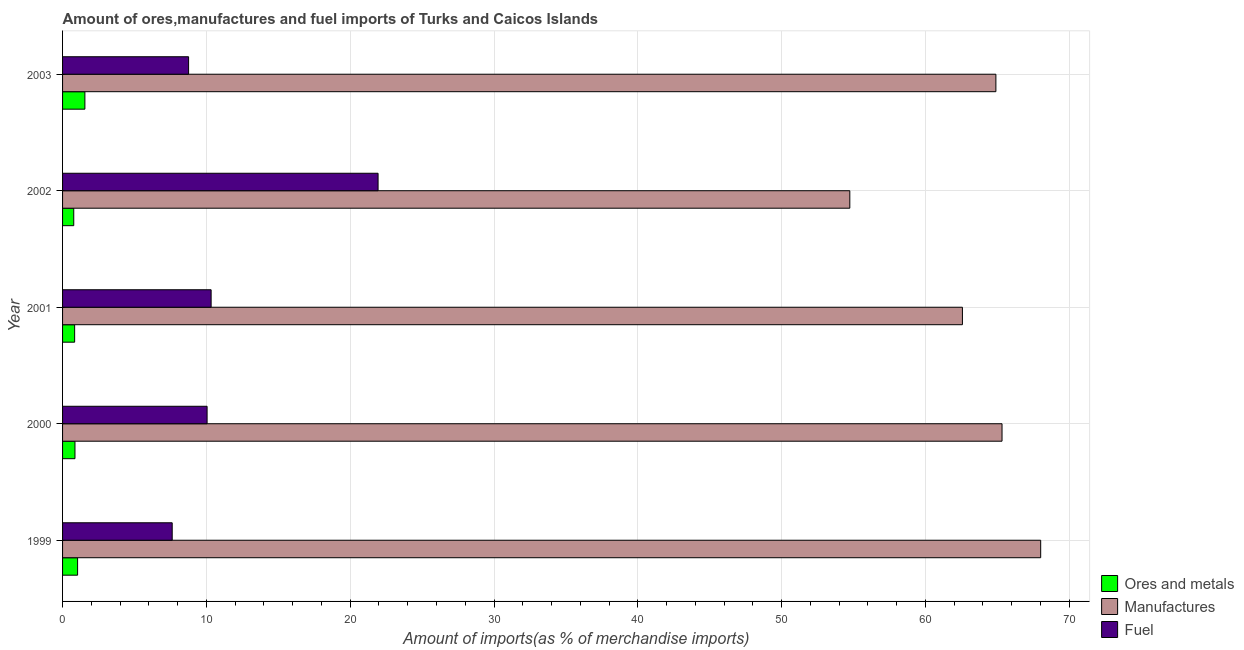How many different coloured bars are there?
Make the answer very short. 3. Are the number of bars per tick equal to the number of legend labels?
Your answer should be very brief. Yes. Are the number of bars on each tick of the Y-axis equal?
Your answer should be very brief. Yes. In how many cases, is the number of bars for a given year not equal to the number of legend labels?
Keep it short and to the point. 0. What is the percentage of manufactures imports in 2003?
Give a very brief answer. 64.9. Across all years, what is the maximum percentage of ores and metals imports?
Ensure brevity in your answer.  1.55. Across all years, what is the minimum percentage of fuel imports?
Keep it short and to the point. 7.62. In which year was the percentage of ores and metals imports maximum?
Ensure brevity in your answer.  2003. What is the total percentage of ores and metals imports in the graph?
Your response must be concise. 5.08. What is the difference between the percentage of fuel imports in 1999 and that in 2003?
Your answer should be very brief. -1.14. What is the difference between the percentage of ores and metals imports in 1999 and the percentage of fuel imports in 2003?
Your answer should be very brief. -7.72. What is the average percentage of fuel imports per year?
Give a very brief answer. 11.74. In the year 2000, what is the difference between the percentage of fuel imports and percentage of manufactures imports?
Your answer should be very brief. -55.28. In how many years, is the percentage of ores and metals imports greater than 4 %?
Make the answer very short. 0. What is the ratio of the percentage of ores and metals imports in 1999 to that in 2002?
Ensure brevity in your answer.  1.34. Is the difference between the percentage of fuel imports in 2001 and 2003 greater than the difference between the percentage of manufactures imports in 2001 and 2003?
Your response must be concise. Yes. What is the difference between the highest and the second highest percentage of ores and metals imports?
Provide a succinct answer. 0.51. What is the difference between the highest and the lowest percentage of fuel imports?
Provide a short and direct response. 14.31. In how many years, is the percentage of ores and metals imports greater than the average percentage of ores and metals imports taken over all years?
Keep it short and to the point. 2. Is the sum of the percentage of ores and metals imports in 2002 and 2003 greater than the maximum percentage of manufactures imports across all years?
Ensure brevity in your answer.  No. What does the 1st bar from the top in 2001 represents?
Provide a succinct answer. Fuel. What does the 2nd bar from the bottom in 2003 represents?
Keep it short and to the point. Manufactures. Is it the case that in every year, the sum of the percentage of ores and metals imports and percentage of manufactures imports is greater than the percentage of fuel imports?
Offer a terse response. Yes. How many bars are there?
Your answer should be compact. 15. How many years are there in the graph?
Give a very brief answer. 5. What is the difference between two consecutive major ticks on the X-axis?
Offer a very short reply. 10. Are the values on the major ticks of X-axis written in scientific E-notation?
Provide a short and direct response. No. Does the graph contain any zero values?
Keep it short and to the point. No. How many legend labels are there?
Make the answer very short. 3. How are the legend labels stacked?
Make the answer very short. Vertical. What is the title of the graph?
Ensure brevity in your answer.  Amount of ores,manufactures and fuel imports of Turks and Caicos Islands. Does "Services" appear as one of the legend labels in the graph?
Offer a very short reply. No. What is the label or title of the X-axis?
Your answer should be compact. Amount of imports(as % of merchandise imports). What is the Amount of imports(as % of merchandise imports) in Ores and metals in 1999?
Provide a succinct answer. 1.04. What is the Amount of imports(as % of merchandise imports) of Manufactures in 1999?
Make the answer very short. 68.01. What is the Amount of imports(as % of merchandise imports) in Fuel in 1999?
Ensure brevity in your answer.  7.62. What is the Amount of imports(as % of merchandise imports) of Ores and metals in 2000?
Offer a terse response. 0.86. What is the Amount of imports(as % of merchandise imports) in Manufactures in 2000?
Make the answer very short. 65.32. What is the Amount of imports(as % of merchandise imports) of Fuel in 2000?
Offer a terse response. 10.05. What is the Amount of imports(as % of merchandise imports) in Ores and metals in 2001?
Make the answer very short. 0.84. What is the Amount of imports(as % of merchandise imports) of Manufactures in 2001?
Offer a very short reply. 62.57. What is the Amount of imports(as % of merchandise imports) in Fuel in 2001?
Your answer should be very brief. 10.33. What is the Amount of imports(as % of merchandise imports) in Ores and metals in 2002?
Keep it short and to the point. 0.78. What is the Amount of imports(as % of merchandise imports) of Manufactures in 2002?
Your answer should be very brief. 54.74. What is the Amount of imports(as % of merchandise imports) in Fuel in 2002?
Offer a terse response. 21.94. What is the Amount of imports(as % of merchandise imports) in Ores and metals in 2003?
Your answer should be compact. 1.55. What is the Amount of imports(as % of merchandise imports) of Manufactures in 2003?
Provide a short and direct response. 64.9. What is the Amount of imports(as % of merchandise imports) of Fuel in 2003?
Ensure brevity in your answer.  8.76. Across all years, what is the maximum Amount of imports(as % of merchandise imports) of Ores and metals?
Make the answer very short. 1.55. Across all years, what is the maximum Amount of imports(as % of merchandise imports) of Manufactures?
Offer a terse response. 68.01. Across all years, what is the maximum Amount of imports(as % of merchandise imports) of Fuel?
Ensure brevity in your answer.  21.94. Across all years, what is the minimum Amount of imports(as % of merchandise imports) in Ores and metals?
Your answer should be compact. 0.78. Across all years, what is the minimum Amount of imports(as % of merchandise imports) in Manufactures?
Your answer should be very brief. 54.74. Across all years, what is the minimum Amount of imports(as % of merchandise imports) in Fuel?
Provide a short and direct response. 7.62. What is the total Amount of imports(as % of merchandise imports) of Ores and metals in the graph?
Give a very brief answer. 5.08. What is the total Amount of imports(as % of merchandise imports) in Manufactures in the graph?
Provide a short and direct response. 315.55. What is the total Amount of imports(as % of merchandise imports) in Fuel in the graph?
Give a very brief answer. 58.7. What is the difference between the Amount of imports(as % of merchandise imports) in Ores and metals in 1999 and that in 2000?
Give a very brief answer. 0.18. What is the difference between the Amount of imports(as % of merchandise imports) in Manufactures in 1999 and that in 2000?
Make the answer very short. 2.69. What is the difference between the Amount of imports(as % of merchandise imports) in Fuel in 1999 and that in 2000?
Your answer should be compact. -2.43. What is the difference between the Amount of imports(as % of merchandise imports) of Ores and metals in 1999 and that in 2001?
Provide a succinct answer. 0.2. What is the difference between the Amount of imports(as % of merchandise imports) in Manufactures in 1999 and that in 2001?
Ensure brevity in your answer.  5.44. What is the difference between the Amount of imports(as % of merchandise imports) in Fuel in 1999 and that in 2001?
Offer a very short reply. -2.71. What is the difference between the Amount of imports(as % of merchandise imports) of Ores and metals in 1999 and that in 2002?
Offer a terse response. 0.27. What is the difference between the Amount of imports(as % of merchandise imports) of Manufactures in 1999 and that in 2002?
Make the answer very short. 13.27. What is the difference between the Amount of imports(as % of merchandise imports) in Fuel in 1999 and that in 2002?
Your answer should be compact. -14.31. What is the difference between the Amount of imports(as % of merchandise imports) in Ores and metals in 1999 and that in 2003?
Your answer should be compact. -0.51. What is the difference between the Amount of imports(as % of merchandise imports) in Manufactures in 1999 and that in 2003?
Make the answer very short. 3.12. What is the difference between the Amount of imports(as % of merchandise imports) in Fuel in 1999 and that in 2003?
Provide a short and direct response. -1.14. What is the difference between the Amount of imports(as % of merchandise imports) in Ores and metals in 2000 and that in 2001?
Make the answer very short. 0.02. What is the difference between the Amount of imports(as % of merchandise imports) of Manufactures in 2000 and that in 2001?
Offer a terse response. 2.75. What is the difference between the Amount of imports(as % of merchandise imports) in Fuel in 2000 and that in 2001?
Keep it short and to the point. -0.28. What is the difference between the Amount of imports(as % of merchandise imports) in Ores and metals in 2000 and that in 2002?
Make the answer very short. 0.08. What is the difference between the Amount of imports(as % of merchandise imports) in Manufactures in 2000 and that in 2002?
Offer a very short reply. 10.58. What is the difference between the Amount of imports(as % of merchandise imports) in Fuel in 2000 and that in 2002?
Keep it short and to the point. -11.89. What is the difference between the Amount of imports(as % of merchandise imports) in Ores and metals in 2000 and that in 2003?
Your response must be concise. -0.69. What is the difference between the Amount of imports(as % of merchandise imports) in Manufactures in 2000 and that in 2003?
Your answer should be compact. 0.43. What is the difference between the Amount of imports(as % of merchandise imports) of Fuel in 2000 and that in 2003?
Make the answer very short. 1.29. What is the difference between the Amount of imports(as % of merchandise imports) in Ores and metals in 2001 and that in 2002?
Offer a very short reply. 0.06. What is the difference between the Amount of imports(as % of merchandise imports) in Manufactures in 2001 and that in 2002?
Your answer should be compact. 7.83. What is the difference between the Amount of imports(as % of merchandise imports) of Fuel in 2001 and that in 2002?
Ensure brevity in your answer.  -11.61. What is the difference between the Amount of imports(as % of merchandise imports) of Ores and metals in 2001 and that in 2003?
Provide a succinct answer. -0.71. What is the difference between the Amount of imports(as % of merchandise imports) of Manufactures in 2001 and that in 2003?
Provide a succinct answer. -2.33. What is the difference between the Amount of imports(as % of merchandise imports) of Fuel in 2001 and that in 2003?
Offer a very short reply. 1.57. What is the difference between the Amount of imports(as % of merchandise imports) in Ores and metals in 2002 and that in 2003?
Ensure brevity in your answer.  -0.77. What is the difference between the Amount of imports(as % of merchandise imports) in Manufactures in 2002 and that in 2003?
Ensure brevity in your answer.  -10.16. What is the difference between the Amount of imports(as % of merchandise imports) in Fuel in 2002 and that in 2003?
Make the answer very short. 13.18. What is the difference between the Amount of imports(as % of merchandise imports) in Ores and metals in 1999 and the Amount of imports(as % of merchandise imports) in Manufactures in 2000?
Provide a succinct answer. -64.28. What is the difference between the Amount of imports(as % of merchandise imports) in Ores and metals in 1999 and the Amount of imports(as % of merchandise imports) in Fuel in 2000?
Ensure brevity in your answer.  -9. What is the difference between the Amount of imports(as % of merchandise imports) of Manufactures in 1999 and the Amount of imports(as % of merchandise imports) of Fuel in 2000?
Provide a succinct answer. 57.96. What is the difference between the Amount of imports(as % of merchandise imports) of Ores and metals in 1999 and the Amount of imports(as % of merchandise imports) of Manufactures in 2001?
Give a very brief answer. -61.53. What is the difference between the Amount of imports(as % of merchandise imports) in Ores and metals in 1999 and the Amount of imports(as % of merchandise imports) in Fuel in 2001?
Keep it short and to the point. -9.29. What is the difference between the Amount of imports(as % of merchandise imports) in Manufactures in 1999 and the Amount of imports(as % of merchandise imports) in Fuel in 2001?
Give a very brief answer. 57.68. What is the difference between the Amount of imports(as % of merchandise imports) in Ores and metals in 1999 and the Amount of imports(as % of merchandise imports) in Manufactures in 2002?
Provide a succinct answer. -53.7. What is the difference between the Amount of imports(as % of merchandise imports) in Ores and metals in 1999 and the Amount of imports(as % of merchandise imports) in Fuel in 2002?
Offer a very short reply. -20.89. What is the difference between the Amount of imports(as % of merchandise imports) in Manufactures in 1999 and the Amount of imports(as % of merchandise imports) in Fuel in 2002?
Your answer should be very brief. 46.07. What is the difference between the Amount of imports(as % of merchandise imports) of Ores and metals in 1999 and the Amount of imports(as % of merchandise imports) of Manufactures in 2003?
Your answer should be compact. -63.85. What is the difference between the Amount of imports(as % of merchandise imports) in Ores and metals in 1999 and the Amount of imports(as % of merchandise imports) in Fuel in 2003?
Your response must be concise. -7.72. What is the difference between the Amount of imports(as % of merchandise imports) of Manufactures in 1999 and the Amount of imports(as % of merchandise imports) of Fuel in 2003?
Your answer should be very brief. 59.25. What is the difference between the Amount of imports(as % of merchandise imports) in Ores and metals in 2000 and the Amount of imports(as % of merchandise imports) in Manufactures in 2001?
Your response must be concise. -61.71. What is the difference between the Amount of imports(as % of merchandise imports) in Ores and metals in 2000 and the Amount of imports(as % of merchandise imports) in Fuel in 2001?
Offer a very short reply. -9.47. What is the difference between the Amount of imports(as % of merchandise imports) in Manufactures in 2000 and the Amount of imports(as % of merchandise imports) in Fuel in 2001?
Provide a short and direct response. 55. What is the difference between the Amount of imports(as % of merchandise imports) of Ores and metals in 2000 and the Amount of imports(as % of merchandise imports) of Manufactures in 2002?
Ensure brevity in your answer.  -53.88. What is the difference between the Amount of imports(as % of merchandise imports) of Ores and metals in 2000 and the Amount of imports(as % of merchandise imports) of Fuel in 2002?
Provide a short and direct response. -21.08. What is the difference between the Amount of imports(as % of merchandise imports) in Manufactures in 2000 and the Amount of imports(as % of merchandise imports) in Fuel in 2002?
Your answer should be very brief. 43.39. What is the difference between the Amount of imports(as % of merchandise imports) in Ores and metals in 2000 and the Amount of imports(as % of merchandise imports) in Manufactures in 2003?
Your response must be concise. -64.04. What is the difference between the Amount of imports(as % of merchandise imports) of Ores and metals in 2000 and the Amount of imports(as % of merchandise imports) of Fuel in 2003?
Your response must be concise. -7.9. What is the difference between the Amount of imports(as % of merchandise imports) in Manufactures in 2000 and the Amount of imports(as % of merchandise imports) in Fuel in 2003?
Offer a terse response. 56.56. What is the difference between the Amount of imports(as % of merchandise imports) of Ores and metals in 2001 and the Amount of imports(as % of merchandise imports) of Manufactures in 2002?
Ensure brevity in your answer.  -53.9. What is the difference between the Amount of imports(as % of merchandise imports) in Ores and metals in 2001 and the Amount of imports(as % of merchandise imports) in Fuel in 2002?
Provide a short and direct response. -21.1. What is the difference between the Amount of imports(as % of merchandise imports) in Manufactures in 2001 and the Amount of imports(as % of merchandise imports) in Fuel in 2002?
Offer a terse response. 40.63. What is the difference between the Amount of imports(as % of merchandise imports) in Ores and metals in 2001 and the Amount of imports(as % of merchandise imports) in Manufactures in 2003?
Your answer should be compact. -64.06. What is the difference between the Amount of imports(as % of merchandise imports) of Ores and metals in 2001 and the Amount of imports(as % of merchandise imports) of Fuel in 2003?
Offer a very short reply. -7.92. What is the difference between the Amount of imports(as % of merchandise imports) in Manufactures in 2001 and the Amount of imports(as % of merchandise imports) in Fuel in 2003?
Your answer should be very brief. 53.81. What is the difference between the Amount of imports(as % of merchandise imports) of Ores and metals in 2002 and the Amount of imports(as % of merchandise imports) of Manufactures in 2003?
Make the answer very short. -64.12. What is the difference between the Amount of imports(as % of merchandise imports) of Ores and metals in 2002 and the Amount of imports(as % of merchandise imports) of Fuel in 2003?
Make the answer very short. -7.99. What is the difference between the Amount of imports(as % of merchandise imports) of Manufactures in 2002 and the Amount of imports(as % of merchandise imports) of Fuel in 2003?
Your response must be concise. 45.98. What is the average Amount of imports(as % of merchandise imports) in Ores and metals per year?
Give a very brief answer. 1.02. What is the average Amount of imports(as % of merchandise imports) of Manufactures per year?
Ensure brevity in your answer.  63.11. What is the average Amount of imports(as % of merchandise imports) of Fuel per year?
Give a very brief answer. 11.74. In the year 1999, what is the difference between the Amount of imports(as % of merchandise imports) of Ores and metals and Amount of imports(as % of merchandise imports) of Manufactures?
Give a very brief answer. -66.97. In the year 1999, what is the difference between the Amount of imports(as % of merchandise imports) of Ores and metals and Amount of imports(as % of merchandise imports) of Fuel?
Make the answer very short. -6.58. In the year 1999, what is the difference between the Amount of imports(as % of merchandise imports) in Manufactures and Amount of imports(as % of merchandise imports) in Fuel?
Ensure brevity in your answer.  60.39. In the year 2000, what is the difference between the Amount of imports(as % of merchandise imports) of Ores and metals and Amount of imports(as % of merchandise imports) of Manufactures?
Ensure brevity in your answer.  -64.46. In the year 2000, what is the difference between the Amount of imports(as % of merchandise imports) of Ores and metals and Amount of imports(as % of merchandise imports) of Fuel?
Provide a short and direct response. -9.19. In the year 2000, what is the difference between the Amount of imports(as % of merchandise imports) in Manufactures and Amount of imports(as % of merchandise imports) in Fuel?
Keep it short and to the point. 55.28. In the year 2001, what is the difference between the Amount of imports(as % of merchandise imports) of Ores and metals and Amount of imports(as % of merchandise imports) of Manufactures?
Make the answer very short. -61.73. In the year 2001, what is the difference between the Amount of imports(as % of merchandise imports) in Ores and metals and Amount of imports(as % of merchandise imports) in Fuel?
Your answer should be very brief. -9.49. In the year 2001, what is the difference between the Amount of imports(as % of merchandise imports) of Manufactures and Amount of imports(as % of merchandise imports) of Fuel?
Your response must be concise. 52.24. In the year 2002, what is the difference between the Amount of imports(as % of merchandise imports) of Ores and metals and Amount of imports(as % of merchandise imports) of Manufactures?
Offer a very short reply. -53.96. In the year 2002, what is the difference between the Amount of imports(as % of merchandise imports) in Ores and metals and Amount of imports(as % of merchandise imports) in Fuel?
Provide a short and direct response. -21.16. In the year 2002, what is the difference between the Amount of imports(as % of merchandise imports) of Manufactures and Amount of imports(as % of merchandise imports) of Fuel?
Your answer should be very brief. 32.8. In the year 2003, what is the difference between the Amount of imports(as % of merchandise imports) of Ores and metals and Amount of imports(as % of merchandise imports) of Manufactures?
Your response must be concise. -63.35. In the year 2003, what is the difference between the Amount of imports(as % of merchandise imports) in Ores and metals and Amount of imports(as % of merchandise imports) in Fuel?
Offer a very short reply. -7.21. In the year 2003, what is the difference between the Amount of imports(as % of merchandise imports) of Manufactures and Amount of imports(as % of merchandise imports) of Fuel?
Provide a short and direct response. 56.13. What is the ratio of the Amount of imports(as % of merchandise imports) in Ores and metals in 1999 to that in 2000?
Make the answer very short. 1.21. What is the ratio of the Amount of imports(as % of merchandise imports) in Manufactures in 1999 to that in 2000?
Your response must be concise. 1.04. What is the ratio of the Amount of imports(as % of merchandise imports) in Fuel in 1999 to that in 2000?
Provide a short and direct response. 0.76. What is the ratio of the Amount of imports(as % of merchandise imports) of Ores and metals in 1999 to that in 2001?
Your answer should be very brief. 1.24. What is the ratio of the Amount of imports(as % of merchandise imports) in Manufactures in 1999 to that in 2001?
Provide a succinct answer. 1.09. What is the ratio of the Amount of imports(as % of merchandise imports) of Fuel in 1999 to that in 2001?
Provide a succinct answer. 0.74. What is the ratio of the Amount of imports(as % of merchandise imports) of Ores and metals in 1999 to that in 2002?
Your answer should be very brief. 1.34. What is the ratio of the Amount of imports(as % of merchandise imports) of Manufactures in 1999 to that in 2002?
Give a very brief answer. 1.24. What is the ratio of the Amount of imports(as % of merchandise imports) in Fuel in 1999 to that in 2002?
Offer a terse response. 0.35. What is the ratio of the Amount of imports(as % of merchandise imports) of Ores and metals in 1999 to that in 2003?
Make the answer very short. 0.67. What is the ratio of the Amount of imports(as % of merchandise imports) of Manufactures in 1999 to that in 2003?
Keep it short and to the point. 1.05. What is the ratio of the Amount of imports(as % of merchandise imports) in Fuel in 1999 to that in 2003?
Keep it short and to the point. 0.87. What is the ratio of the Amount of imports(as % of merchandise imports) of Ores and metals in 2000 to that in 2001?
Your answer should be very brief. 1.03. What is the ratio of the Amount of imports(as % of merchandise imports) in Manufactures in 2000 to that in 2001?
Ensure brevity in your answer.  1.04. What is the ratio of the Amount of imports(as % of merchandise imports) in Fuel in 2000 to that in 2001?
Your answer should be very brief. 0.97. What is the ratio of the Amount of imports(as % of merchandise imports) in Ores and metals in 2000 to that in 2002?
Your answer should be compact. 1.11. What is the ratio of the Amount of imports(as % of merchandise imports) of Manufactures in 2000 to that in 2002?
Make the answer very short. 1.19. What is the ratio of the Amount of imports(as % of merchandise imports) of Fuel in 2000 to that in 2002?
Provide a succinct answer. 0.46. What is the ratio of the Amount of imports(as % of merchandise imports) in Ores and metals in 2000 to that in 2003?
Provide a short and direct response. 0.56. What is the ratio of the Amount of imports(as % of merchandise imports) in Manufactures in 2000 to that in 2003?
Ensure brevity in your answer.  1.01. What is the ratio of the Amount of imports(as % of merchandise imports) in Fuel in 2000 to that in 2003?
Provide a short and direct response. 1.15. What is the ratio of the Amount of imports(as % of merchandise imports) of Ores and metals in 2001 to that in 2002?
Make the answer very short. 1.08. What is the ratio of the Amount of imports(as % of merchandise imports) of Manufactures in 2001 to that in 2002?
Ensure brevity in your answer.  1.14. What is the ratio of the Amount of imports(as % of merchandise imports) of Fuel in 2001 to that in 2002?
Provide a short and direct response. 0.47. What is the ratio of the Amount of imports(as % of merchandise imports) in Ores and metals in 2001 to that in 2003?
Provide a succinct answer. 0.54. What is the ratio of the Amount of imports(as % of merchandise imports) in Manufactures in 2001 to that in 2003?
Offer a terse response. 0.96. What is the ratio of the Amount of imports(as % of merchandise imports) of Fuel in 2001 to that in 2003?
Give a very brief answer. 1.18. What is the ratio of the Amount of imports(as % of merchandise imports) in Ores and metals in 2002 to that in 2003?
Ensure brevity in your answer.  0.5. What is the ratio of the Amount of imports(as % of merchandise imports) of Manufactures in 2002 to that in 2003?
Provide a short and direct response. 0.84. What is the ratio of the Amount of imports(as % of merchandise imports) in Fuel in 2002 to that in 2003?
Your response must be concise. 2.5. What is the difference between the highest and the second highest Amount of imports(as % of merchandise imports) in Ores and metals?
Your answer should be very brief. 0.51. What is the difference between the highest and the second highest Amount of imports(as % of merchandise imports) of Manufactures?
Make the answer very short. 2.69. What is the difference between the highest and the second highest Amount of imports(as % of merchandise imports) of Fuel?
Provide a succinct answer. 11.61. What is the difference between the highest and the lowest Amount of imports(as % of merchandise imports) in Ores and metals?
Give a very brief answer. 0.77. What is the difference between the highest and the lowest Amount of imports(as % of merchandise imports) of Manufactures?
Provide a succinct answer. 13.27. What is the difference between the highest and the lowest Amount of imports(as % of merchandise imports) of Fuel?
Offer a very short reply. 14.31. 